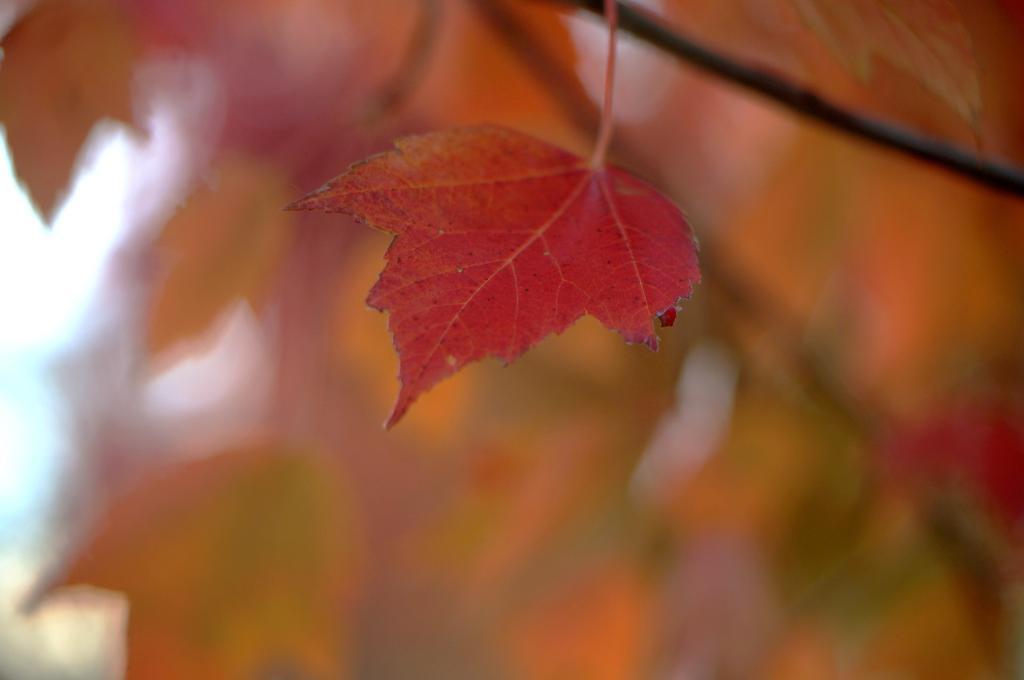Describe this image in one or two sentences. In the image we can see a leaf, Behind the leaf the image is blur. 